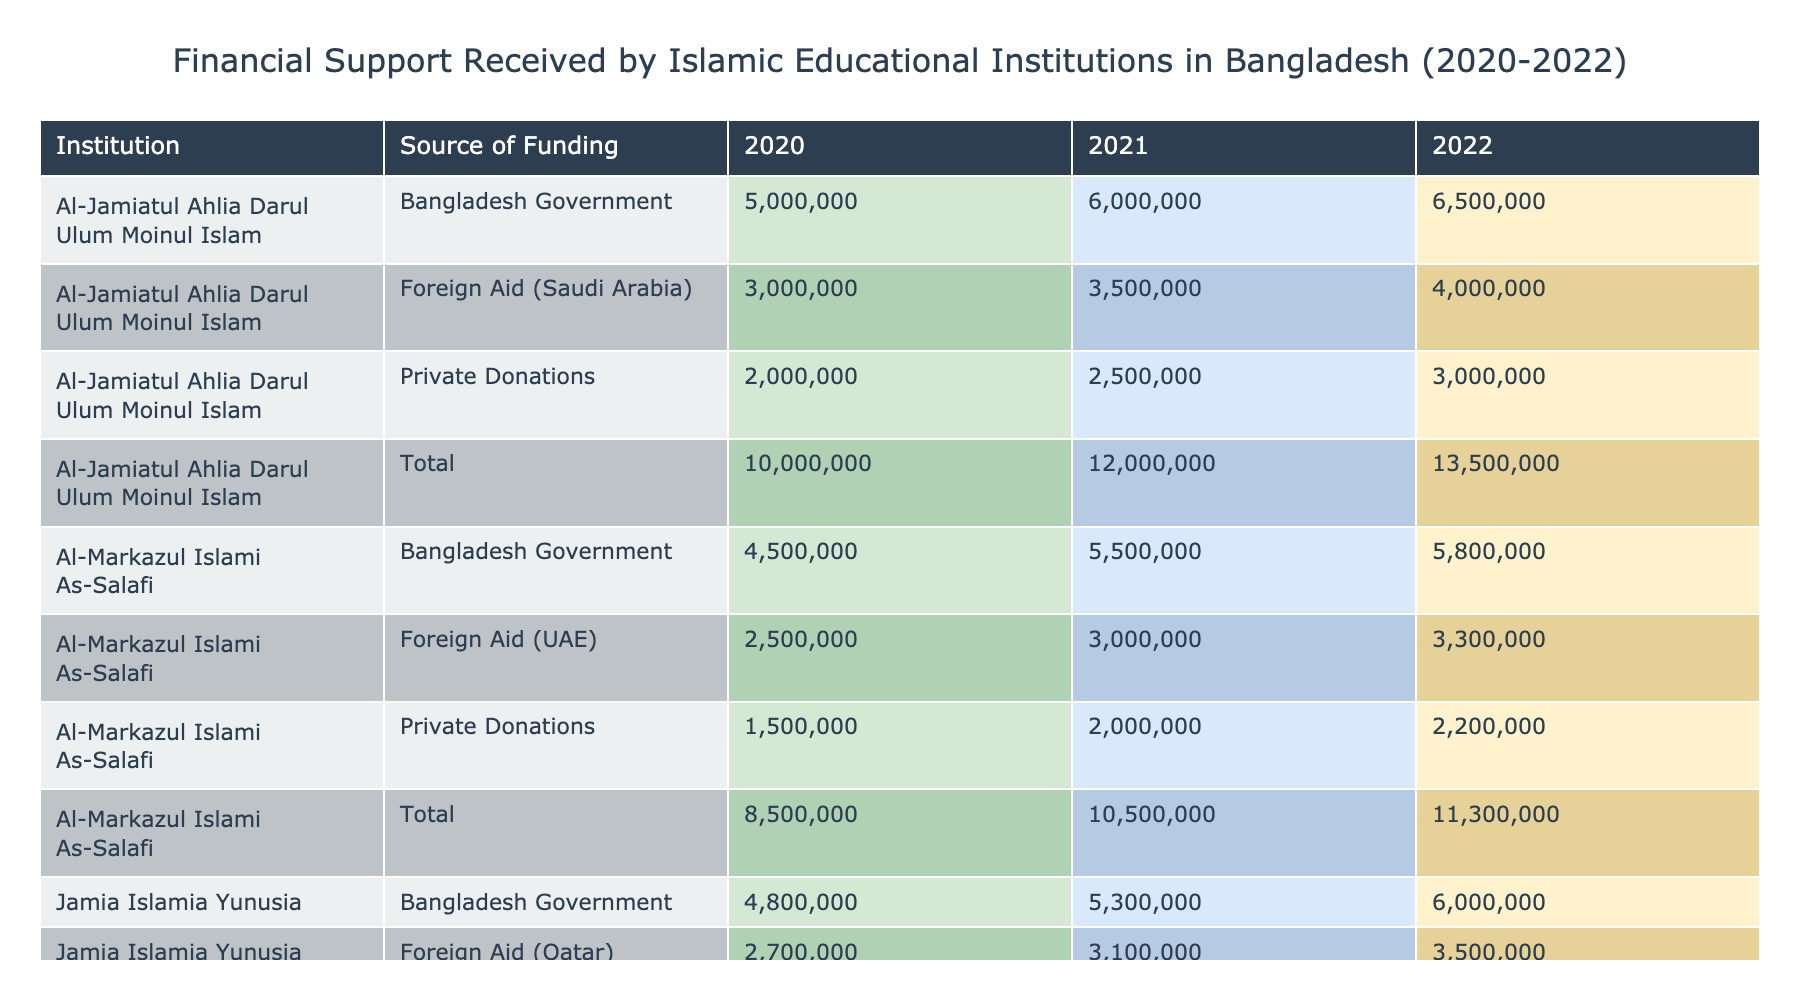What was the total financial support received by Al-Jamiatul Ahlia Darul Ulum Moinul Islam in 2021? The table shows that in 2021, Al-Jamiatul Ahlia Darul Ulum Moinul Islam received three amounts: 6,000,000 BDT from the Bangladesh Government, 2,500,000 BDT from Private Donations, and 3,500,000 BDT from Foreign Aid (Saudi Arabia). To find the total, we sum these amounts: 6,000,000 + 2,500,000 + 3,500,000 = 12,000,000 BDT.
Answer: 12,000,000 BDT In which year did Jamia Islamia Yunusia receive the most funding? By examining the table, we can see the funding amounts for Jamia Islamia Yunusia across all three years: 4,800,000 BDT in 2020, 5,300,000 BDT in 2021, and 6,000,000 BDT in 2022. The highest amount is 6,000,000 BDT, which was received in 2022.
Answer: 2022 Was the total funding received from Foreign Aid (UAE) by Al-Markazul Islami As-Salafi more than the total funding from Private Donations in 2020? In 2020, Al-Markazul Islami As-Salafi received 2,500,000 BDT from Foreign Aid (UAE) and 1,500,000 BDT from Private Donations. To determine if the Foreign Aid total is more than the Private Donations total, we compare these amounts. 2,500,000 BDT > 1,500,000 BDT is true.
Answer: Yes What is the average amount of funding received by all institutions in 2022? To find the average, we need to sum the amounts received in 2022: Al-Jamiatul Ahlia: 6,500,000 + 3,000,000 + 4,000,000; Al-Markazul Islami: 5,800,000 + 2,200,000 + 3,300,000; Jamia Islamia: 6,000,000 + 2,600,000 + 3,500,000. The sums are 13,500,000 BDT for Al-Jamiatul, 11,300,000 BDT for Al-Markazul, and 12,100,000 BDT for Jamia Islamia, which totals 36,900,000 BDT. Dividing this sum by 3 institutions gives an average of 12,300,000 BDT.
Answer: 12,300,000 BDT Did any institution receive more than 2,500,000 BDT from Private Donations in 2021? The table shows the amounts from Private Donations in 2021: Al-Jamiatul Ahlia Darul Ulum Moinul Islam received 2,500,000 BDT, Al-Markazul Islami As-Salafi received 2,000,000 BDT, and Jamia Islamia Yunusia received 2,100,000 BDT. None of these amounts exceed 2,500,000 BDT.
Answer: No 